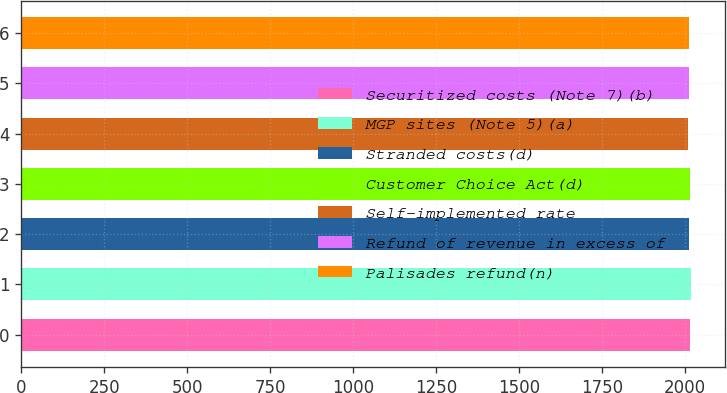<chart> <loc_0><loc_0><loc_500><loc_500><bar_chart><fcel>Securitized costs (Note 7)(b)<fcel>MGP sites (Note 5)(a)<fcel>Stranded costs(d)<fcel>Customer Choice Act(d)<fcel>Self-implemented rate<fcel>Refund of revenue in excess of<fcel>Palisades refund(n)<nl><fcel>2015.5<fcel>2020<fcel>2013.7<fcel>2014.6<fcel>2011<fcel>2011.9<fcel>2012.8<nl></chart> 